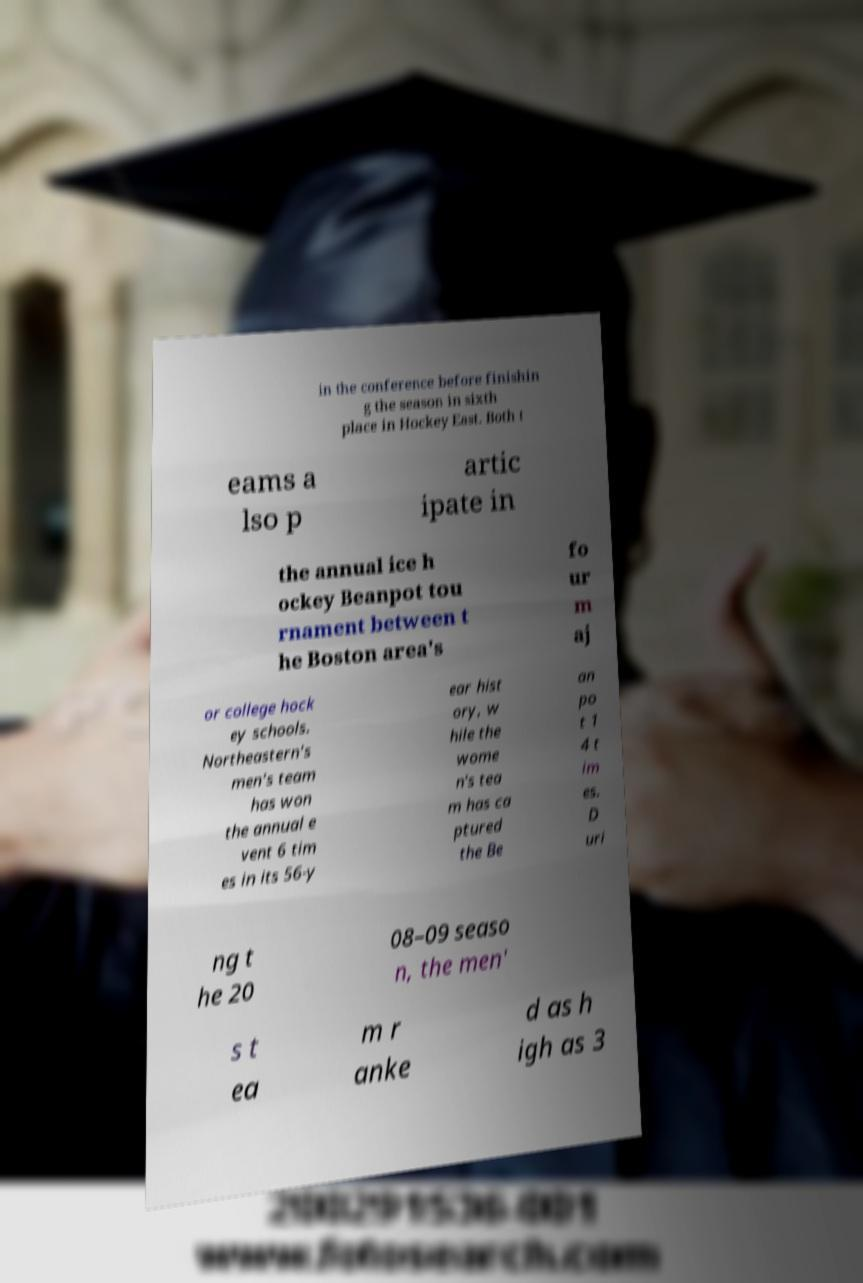Could you extract and type out the text from this image? in the conference before finishin g the season in sixth place in Hockey East. Both t eams a lso p artic ipate in the annual ice h ockey Beanpot tou rnament between t he Boston area's fo ur m aj or college hock ey schools. Northeastern's men's team has won the annual e vent 6 tim es in its 56-y ear hist ory, w hile the wome n's tea m has ca ptured the Be an po t 1 4 t im es. D uri ng t he 20 08–09 seaso n, the men' s t ea m r anke d as h igh as 3 